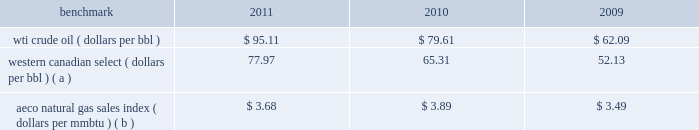A significant portion of our natural gas production in the lower 48 states of the u.s .
Is sold at bid-week prices or first-of-month indices relative to our specific producing areas .
Average settlement date henry hub natural gas prices have been relatively stable for the periods of this report ; however , a decline began in september 2011 which has continued in 2012 with february averaging $ 2.68 per mmbtu .
Should u.s .
Natural gas prices remain depressed , an impairment charge related to our natural gas assets may be necessary .
Our other major natural gas-producing regions are europe and eg .
Natural gas prices in europe have been significantly higher than in the u.s .
In the case of eg our natural gas sales are subject to term contracts , making realized prices less volatile .
The natural gas sales from eg are at fixed prices ; therefore , our worldwide reported average natural gas realized prices may not fully track market price movements .
Oil sands mining osm segment revenues correlate with prevailing market prices for the various qualities of synthetic crude oil we produce .
Roughly two-thirds of the normal output mix will track movements in wti and one-third will track movements in the canadian heavy sour crude oil marker , primarily western canadian select .
Output mix can be impacted by operational problems or planned unit outages at the mines or the upgrader .
The operating cost structure of the oil sands mining operations is predominantly fixed and therefore many of the costs incurred in times of full operation continue during production downtime .
Per-unit costs are sensitive to production rates .
Key variable costs are natural gas and diesel fuel , which track commodity markets such as the canadian alberta energy company ( 201caeco 201d ) natural gas sales index and crude oil prices , respectively .
Recently aeco prices have declined , much as henry hub prices have .
We would expect a significant , continued declined in natural gas prices to have a favorable impact on osm operating costs .
The table below shows average benchmark prices that impact both our revenues and variable costs. .
Wti crude oil ( dollars per bbl ) $ 95.11 $ 79.61 $ 62.09 western canadian select ( dollars per bbl ) ( a ) 77.97 65.31 52.13 aeco natural gas sales index ( dollars per mmbtu ) ( b ) $ 3.68 $ 3.89 $ 3.49 ( a ) monthly pricing based upon average wti adjusted for differentials unique to western canada .
( b ) monthly average day ahead index .
Integrated gas our integrated gas operations include production and marketing of products manufactured from natural gas , such as lng and methanol , in eg .
World lng trade in 2011 has been estimated to be 241 mmt .
Long-term , lng continues to be in demand as markets seek the benefits of clean burning natural gas .
Market prices for lng are not reported or posted .
In general , lng delivered to the u.s .
Is tied to henry hub prices and will track with changes in u.s .
Natural gas prices , while lng sold in europe and asia is indexed to crude oil prices and will track the movement of those prices .
We have a 60 percent ownership in an lng production facility in equatorial guinea , which sells lng under a long-term contract at prices tied to henry hub natural gas prices .
Gross sales from the plant were 4.1 mmt , 3.7 mmt and 3.9 mmt in 2011 , 2010 and 2009 .
We own a 45 percent interest in a methanol plant located in equatorial guinea through our investment in ampco .
Gross sales of methanol from the plant totaled 1039657 , 850605 and 960374 metric tonnes in 2011 , 2010 and 2009 .
Methanol demand has a direct impact on ampco 2019s earnings .
Because global demand for methanol is rather limited , changes in the supply-demand balance can have a significant impact on sales prices .
World demand for methanol in 2011 has been estimated to be 55.4 mmt .
Our plant capacity of 1.1 mmt is about 2 percent of total demand .
Operating and financial highlights significant operating and financial highlights during 2011 include : 2022 completed the spin-off of our downstream business on june 30 , 2011 2022 acquired a significant operated position in the eagle ford shale play in south texas 2022 added net proved reserves , for the e&p and osm segments combined , of 307 mmboe , excluding dispositions , for a 212 percent reserve replacement ratio .
How much has the wti crude oil dollars per bbl increased since 2009? 
Computations: ((95.11 - 62.09) / 62.09)
Answer: 0.53181. 